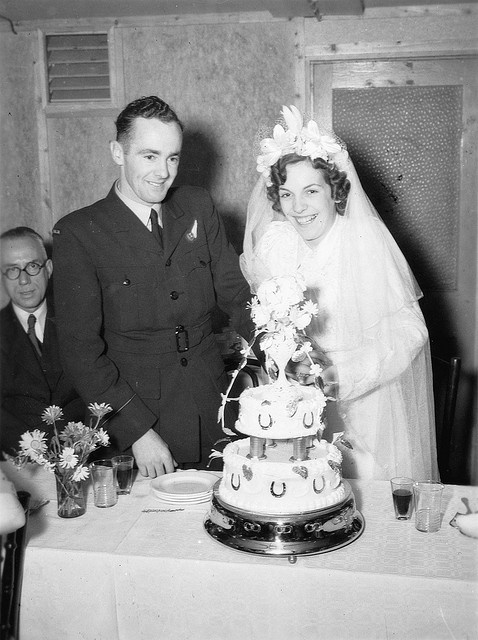Describe the objects in this image and their specific colors. I can see people in gray, black, lightgray, and darkgray tones, dining table in gray, lightgray, darkgray, and black tones, people in gray, lightgray, darkgray, and black tones, people in gray, black, darkgray, and lightgray tones, and cake in gray, lightgray, darkgray, and black tones in this image. 